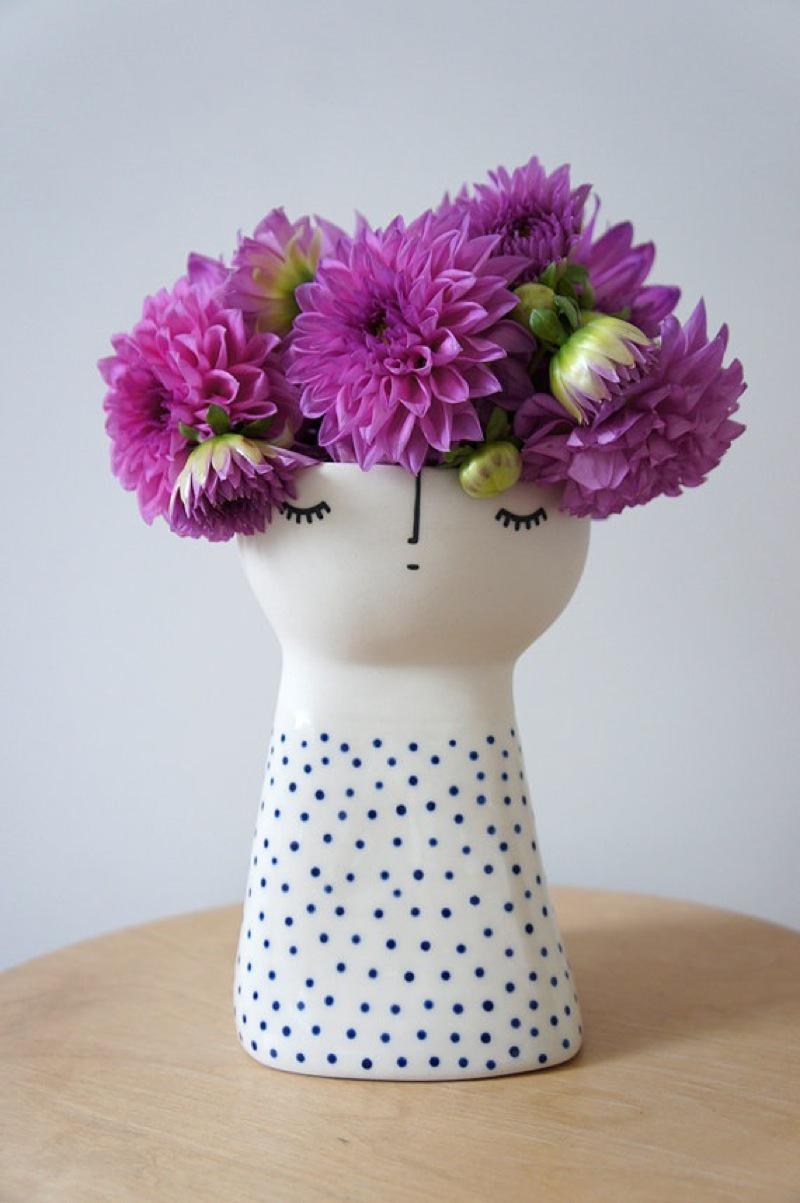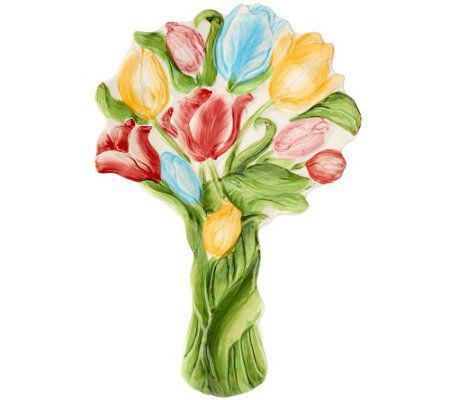The first image is the image on the left, the second image is the image on the right. For the images shown, is this caption "There are at least five pink flowers with some green leaves set in a square vase to reveal the top of the flowers." true? Answer yes or no. No. 